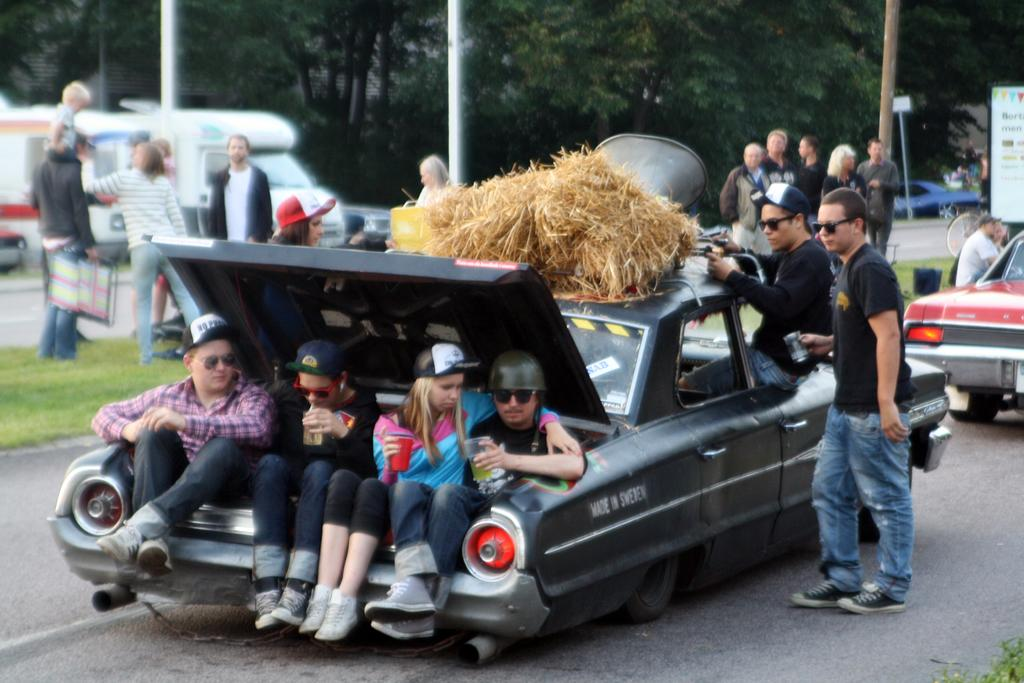What are the people doing in the image? There are people standing beside a car and sitting at a back desk. What is on top of the car in the image? There is dry grass on top of the car. What can be seen in the distance in the image? There are trees visible in the background. What degree of difficulty is the roll facing in the image? There is no roll present in the image, so it is not possible to determine the degree of difficulty it might be facing. 